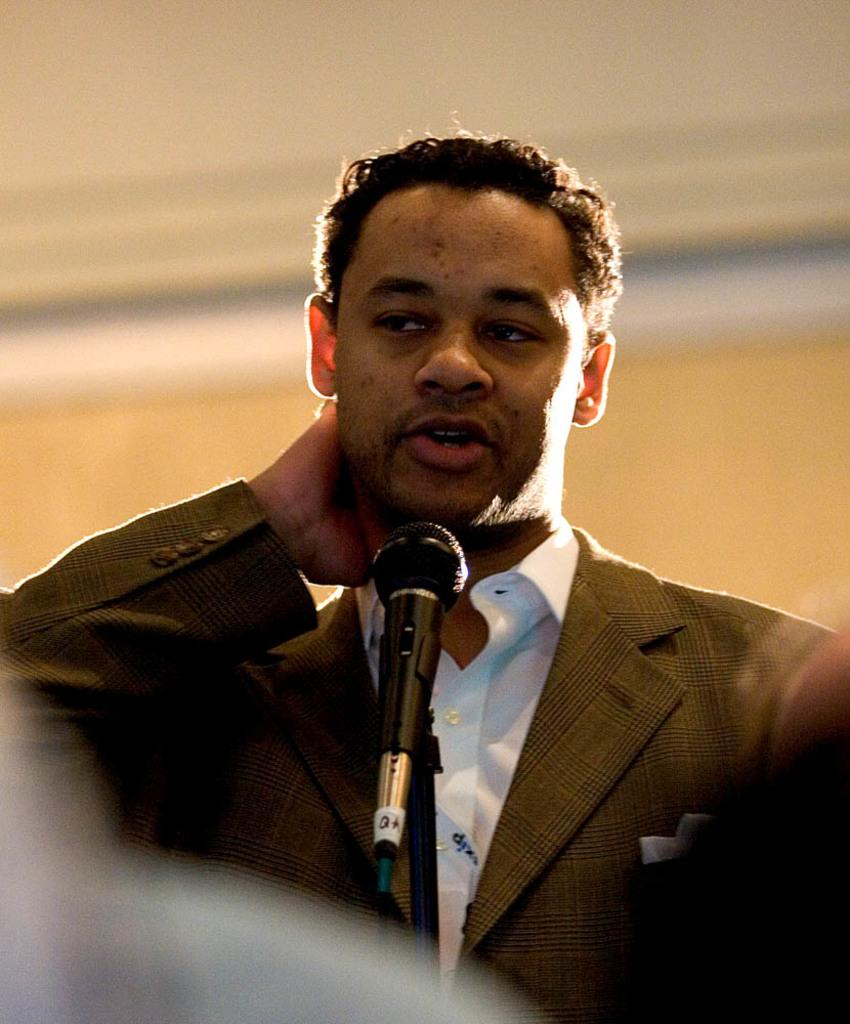Who or what is in the image? There is a person in the image. What is the person doing in the image? The person is in front of a microphone. What can be seen behind the person? There is a wall in the image. Where might this image have been taken? The image may have been taken in a hall, given the presence of a wall and a microphone. What type of kite is the person flying in the image? There is no kite present in the image; the person is in front of a microphone. What type of poison is the person handling in the image? There is no poison present in the image; the person is in front of a microphone. 